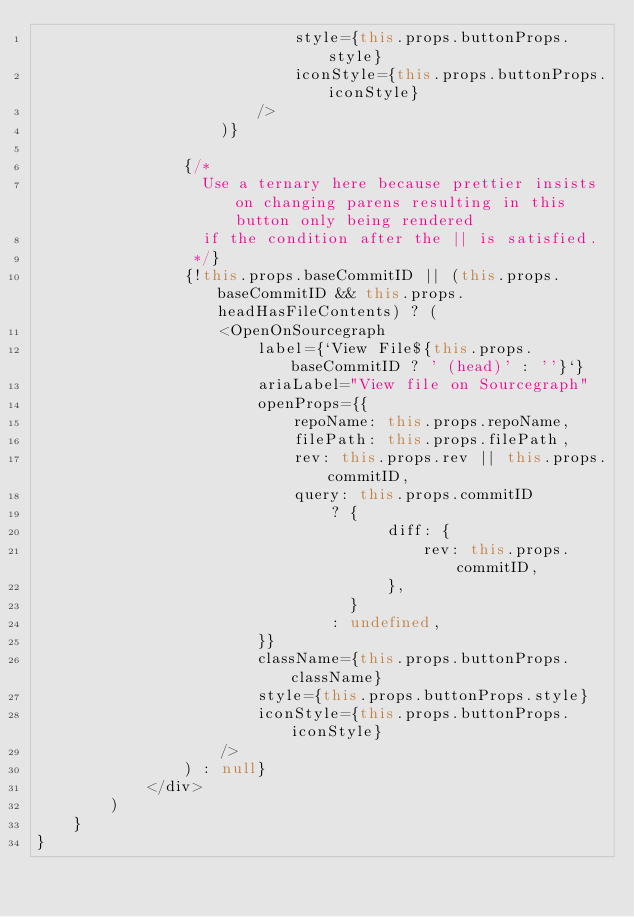Convert code to text. <code><loc_0><loc_0><loc_500><loc_500><_TypeScript_>                            style={this.props.buttonProps.style}
                            iconStyle={this.props.buttonProps.iconStyle}
                        />
                    )}

                {/*
                  Use a ternary here because prettier insists on changing parens resulting in this button only being rendered
                  if the condition after the || is satisfied.
                 */}
                {!this.props.baseCommitID || (this.props.baseCommitID && this.props.headHasFileContents) ? (
                    <OpenOnSourcegraph
                        label={`View File${this.props.baseCommitID ? ' (head)' : ''}`}
                        ariaLabel="View file on Sourcegraph"
                        openProps={{
                            repoName: this.props.repoName,
                            filePath: this.props.filePath,
                            rev: this.props.rev || this.props.commitID,
                            query: this.props.commitID
                                ? {
                                      diff: {
                                          rev: this.props.commitID,
                                      },
                                  }
                                : undefined,
                        }}
                        className={this.props.buttonProps.className}
                        style={this.props.buttonProps.style}
                        iconStyle={this.props.buttonProps.iconStyle}
                    />
                ) : null}
            </div>
        )
    }
}
</code> 